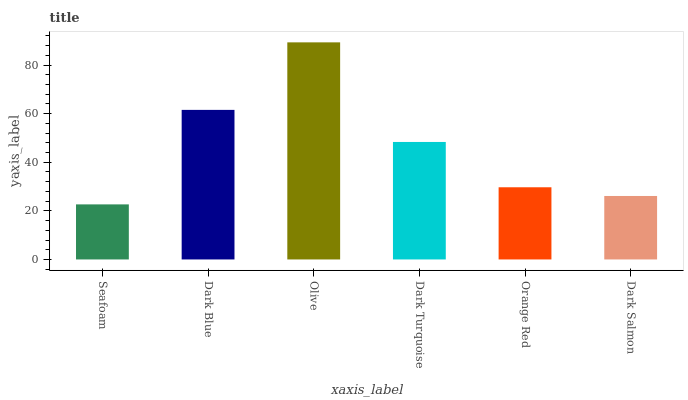Is Seafoam the minimum?
Answer yes or no. Yes. Is Olive the maximum?
Answer yes or no. Yes. Is Dark Blue the minimum?
Answer yes or no. No. Is Dark Blue the maximum?
Answer yes or no. No. Is Dark Blue greater than Seafoam?
Answer yes or no. Yes. Is Seafoam less than Dark Blue?
Answer yes or no. Yes. Is Seafoam greater than Dark Blue?
Answer yes or no. No. Is Dark Blue less than Seafoam?
Answer yes or no. No. Is Dark Turquoise the high median?
Answer yes or no. Yes. Is Orange Red the low median?
Answer yes or no. Yes. Is Seafoam the high median?
Answer yes or no. No. Is Dark Blue the low median?
Answer yes or no. No. 